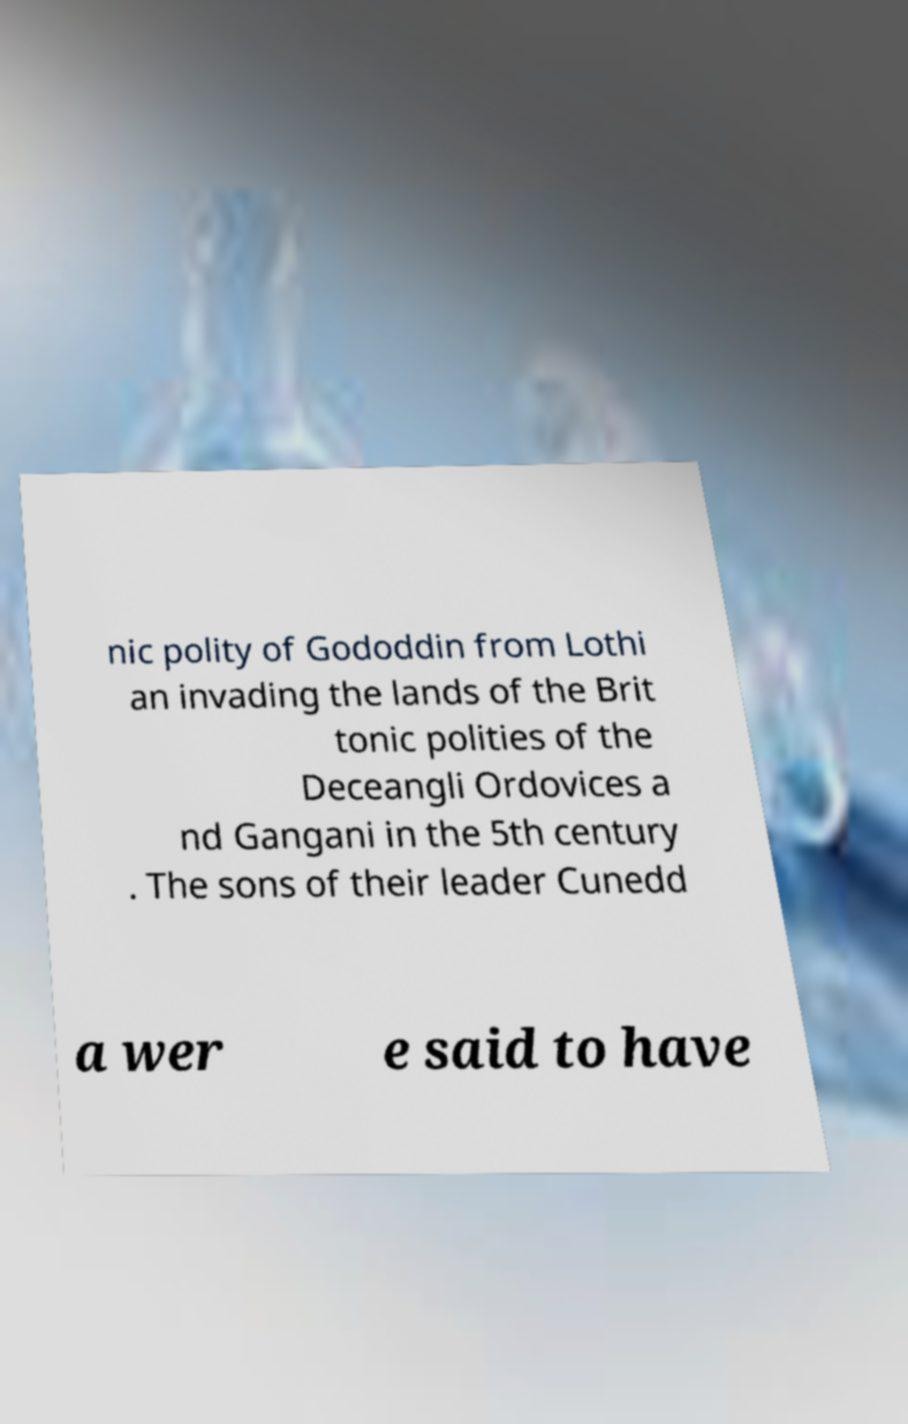Please identify and transcribe the text found in this image. nic polity of Gododdin from Lothi an invading the lands of the Brit tonic polities of the Deceangli Ordovices a nd Gangani in the 5th century . The sons of their leader Cunedd a wer e said to have 